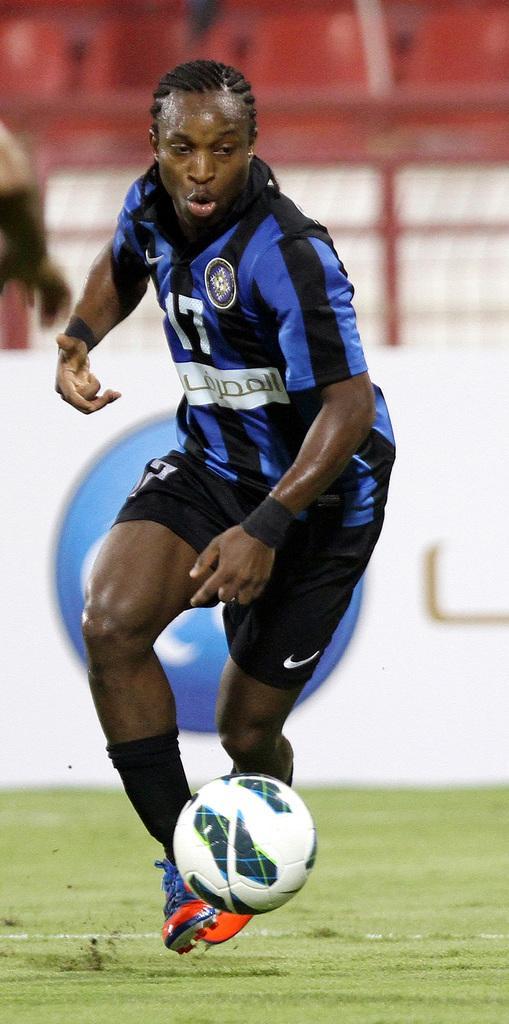How would you summarize this image in a sentence or two? A person wearing a blue and a black dress is playing football and football is in front of him. And it is green lawn. 